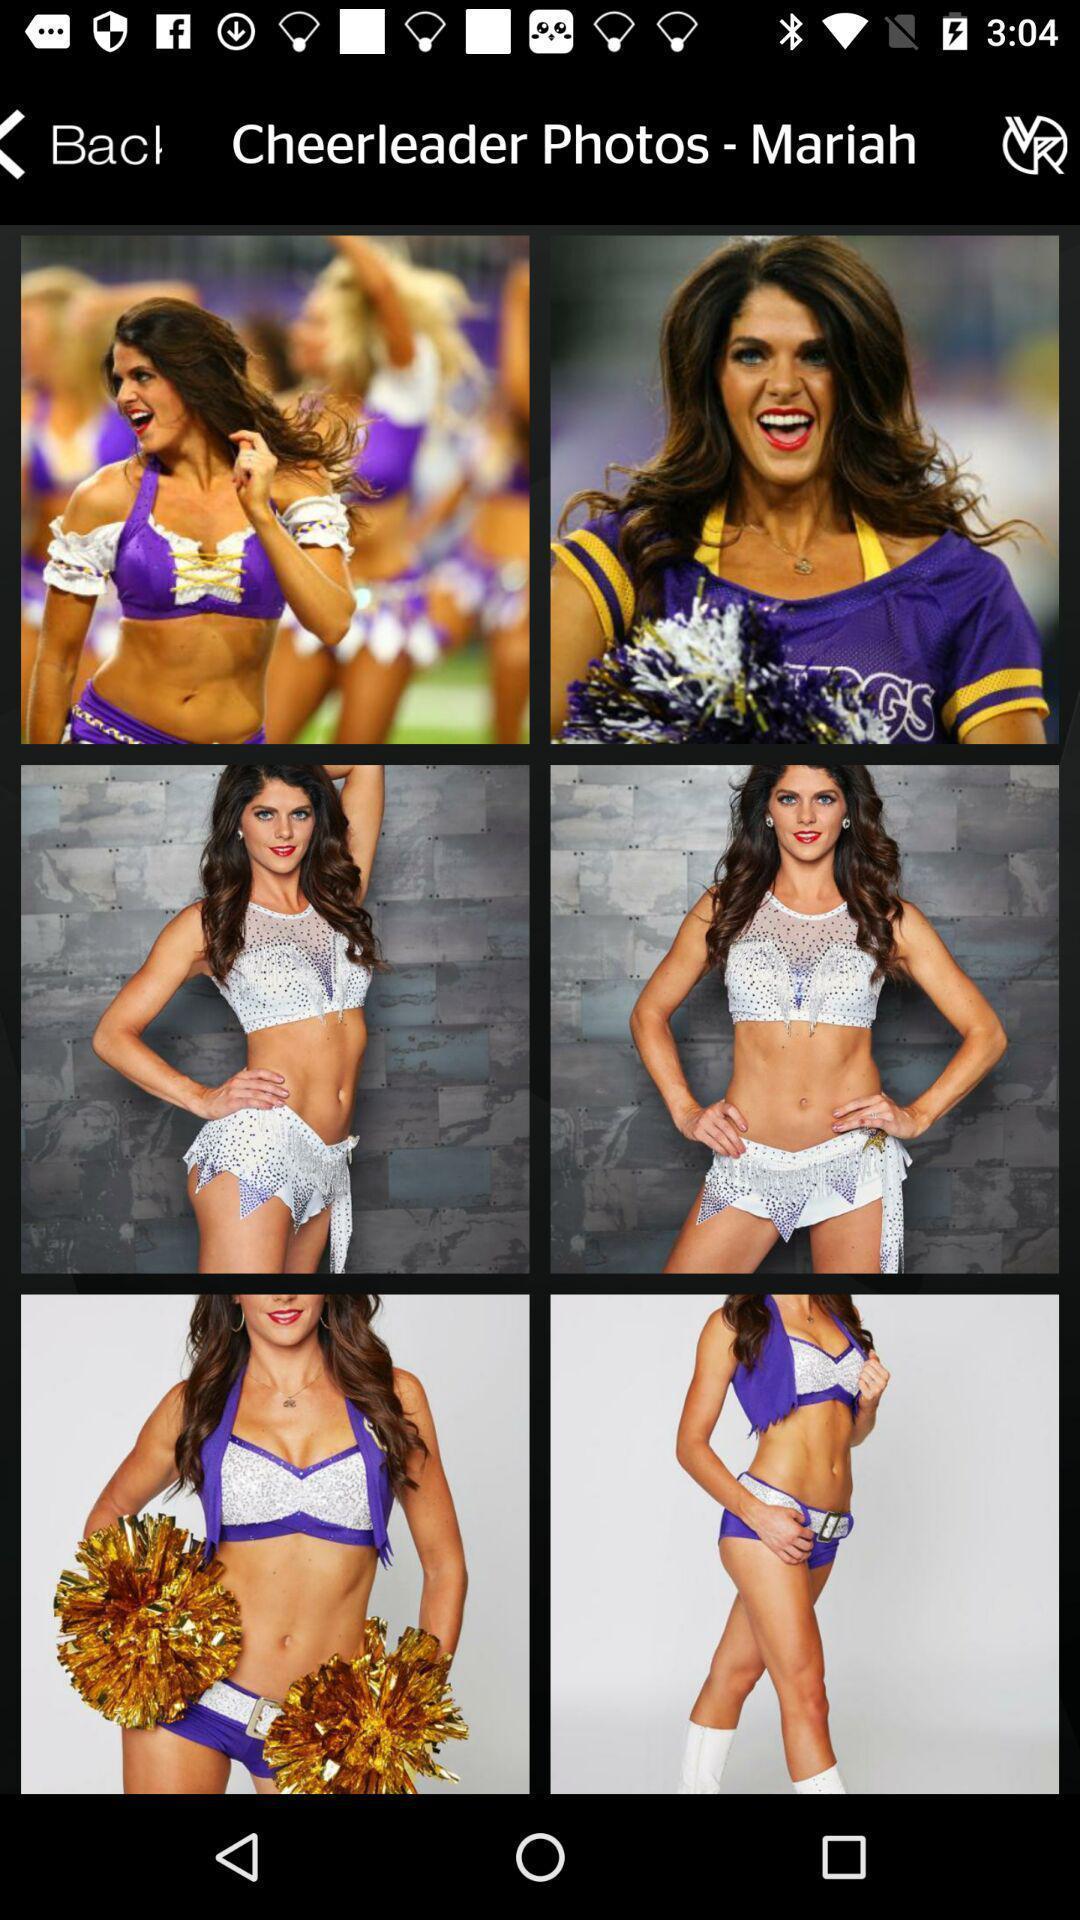What details can you identify in this image? Various female images displayed. 